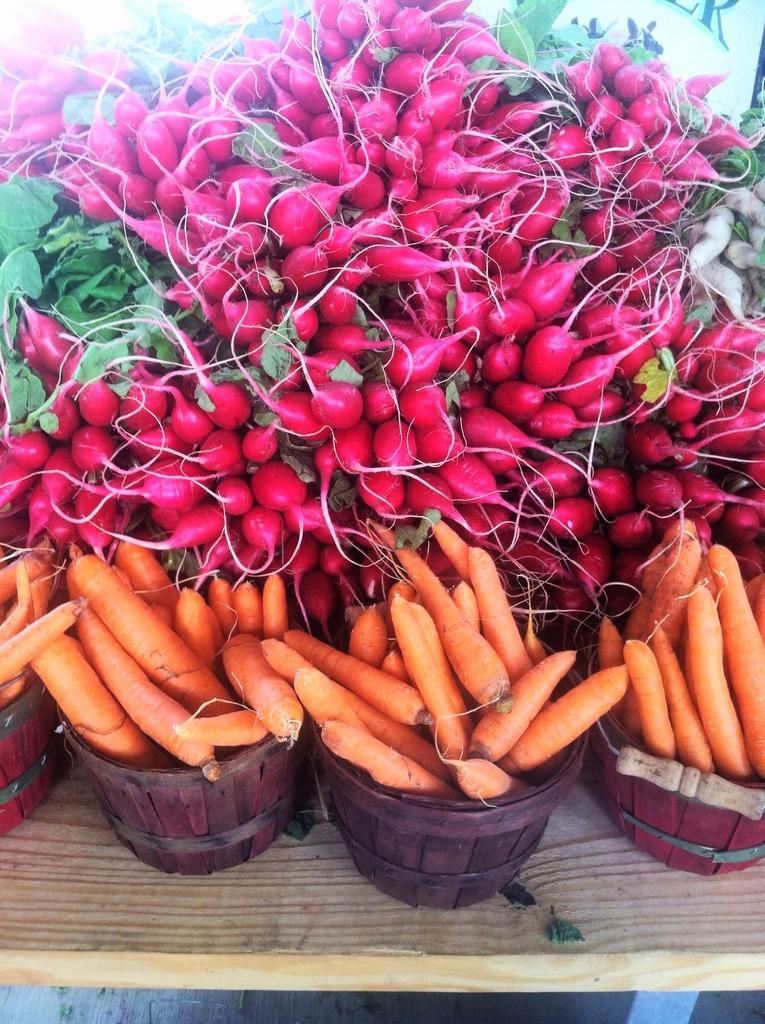What type of food can be seen in the image? There are carrots in the image. Are there any other types of food visible in the image? Yes, there are other vegetables in the image. How are the vegetables stored in the image? The vegetables are kept in drums. How many lizards can be seen crawling on the vegetables in the image? There are no lizards present in the image; it only features vegetables stored in drums. 